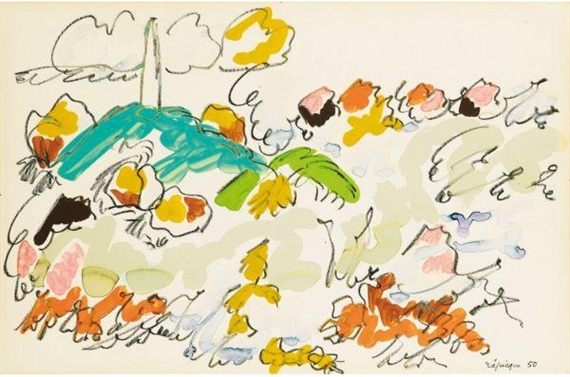What might be the artist's intention behind this abstract expressionist piece? In this abstract expressionist piece, the artist likely intends to evoke emotions and thoughts through spontaneity and the visceral qualities of paint. Abstract Expressionism often focuses not just on visual representations but on the act of painting itself as an emotional or existential gesture. By using fluid forms and vibrant colors, the artist invites viewers to interpret the artwork in personal ways, possibly as an exploration of inner emotions, an abstract landscape, or a metaphorical expression of life’s chaos and beauty. 